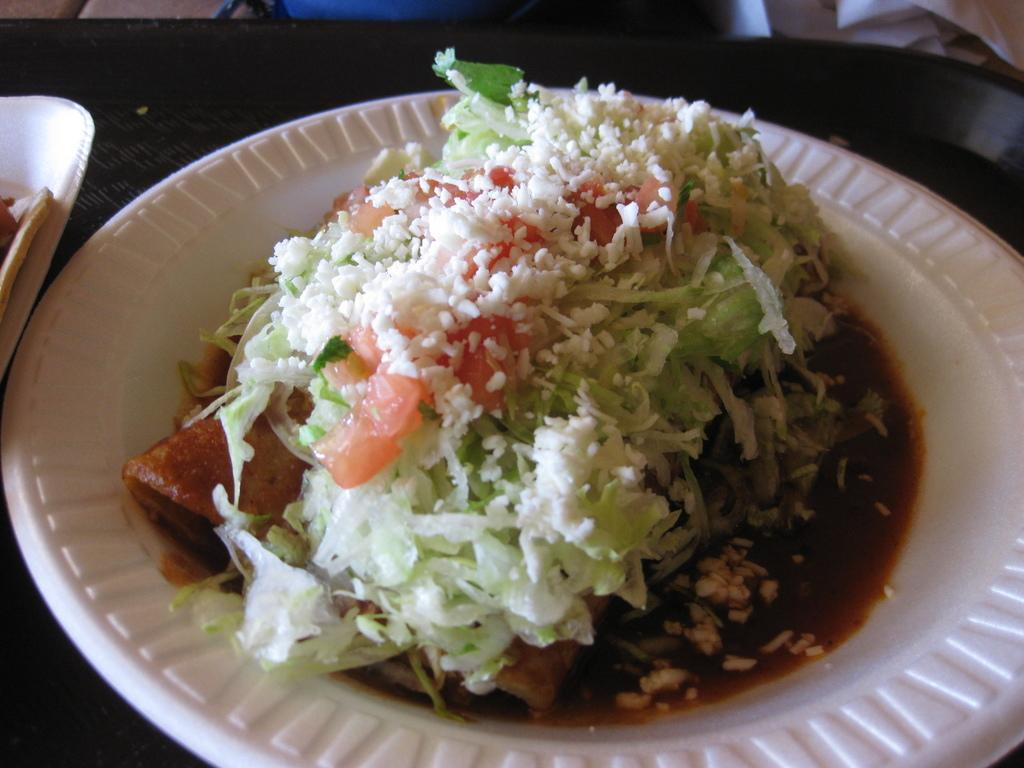How many plates are visible in the image? There are two plates in the image. What is on the plates? The plates contain food. Where are the plates located? The plates are placed on a table. What type of lace can be seen on the plates in the image? There is no lace present on the plates in the image. 